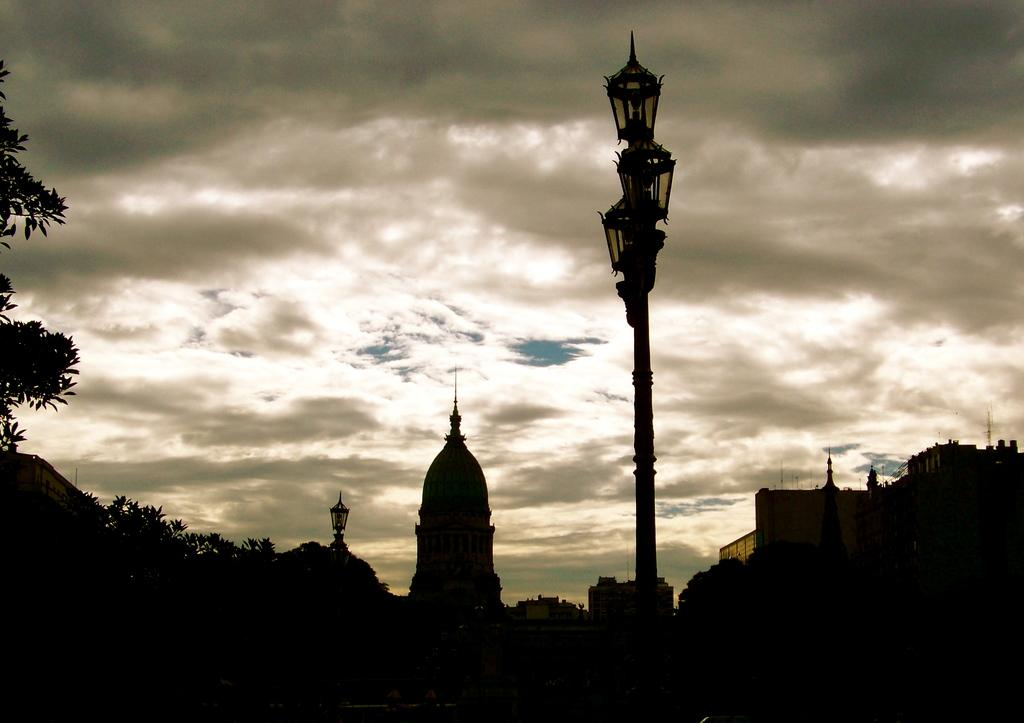What type of natural elements can be seen in the image? There are trees in the image. What type of artificial elements can be seen in the image? There are street lights and buildings in the image. How would you describe the lighting at the bottom of the picture? The bottom of the picture has a dark view. What is the condition of the sky in the image? The sky is cloudy in the image. Can you see any pots on the island in the image? There is no island present in the image, and therefore no pots can be seen on it. 